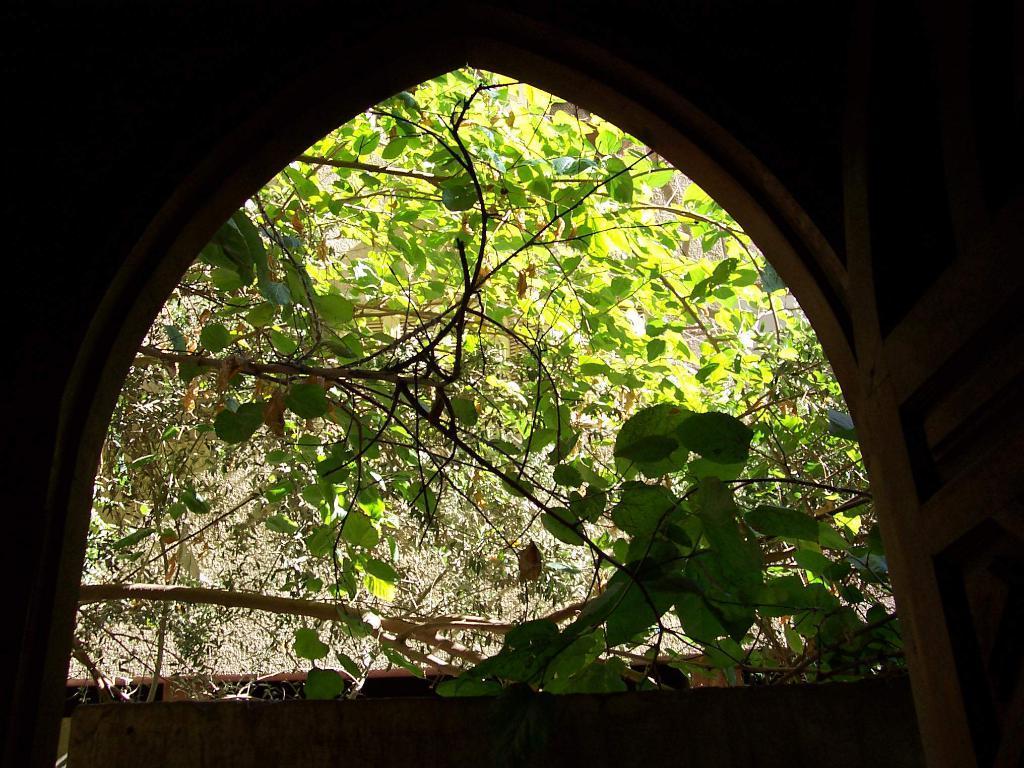How would you summarize this image in a sentence or two? In the center of the image there is a wall and a few other objects. In the background we can see trees, plants, one wooden object and a few other objects. 